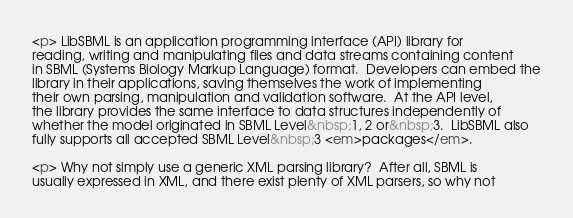Convert code to text. <code><loc_0><loc_0><loc_500><loc_500><_HTML_><p> LibSBML is an application programming interface (API) library for
reading, writing and manipulating files and data streams containing content
in SBML (Systems Biology Markup Language) format.  Developers can embed the
library in their applications, saving themselves the work of implementing
their own parsing, manipulation and validation software.  At the API level,
the library provides the same interface to data structures independently of
whether the model originated in SBML Level&nbsp;1, 2 or&nbsp;3.  LibSBML also
fully supports all accepted SBML Level&nbsp;3 <em>packages</em>.  

<p> Why not simply use a generic XML parsing library?  After all, SBML is
usually expressed in XML, and there exist plenty of XML parsers, so why not</code> 